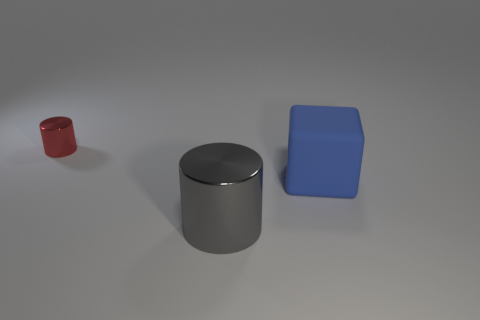Add 1 big purple things. How many objects exist? 4 Subtract all cylinders. How many objects are left? 1 Add 2 red metallic cylinders. How many red metallic cylinders are left? 3 Add 1 big cubes. How many big cubes exist? 2 Subtract 0 green cylinders. How many objects are left? 3 Subtract all gray objects. Subtract all cyan metal things. How many objects are left? 2 